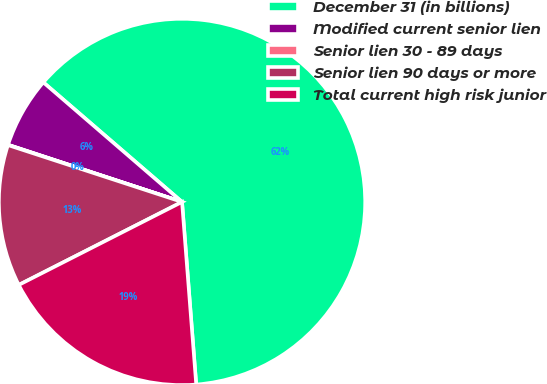Convert chart to OTSL. <chart><loc_0><loc_0><loc_500><loc_500><pie_chart><fcel>December 31 (in billions)<fcel>Modified current senior lien<fcel>Senior lien 30 - 89 days<fcel>Senior lien 90 days or more<fcel>Total current high risk junior<nl><fcel>62.44%<fcel>6.27%<fcel>0.03%<fcel>12.51%<fcel>18.75%<nl></chart> 